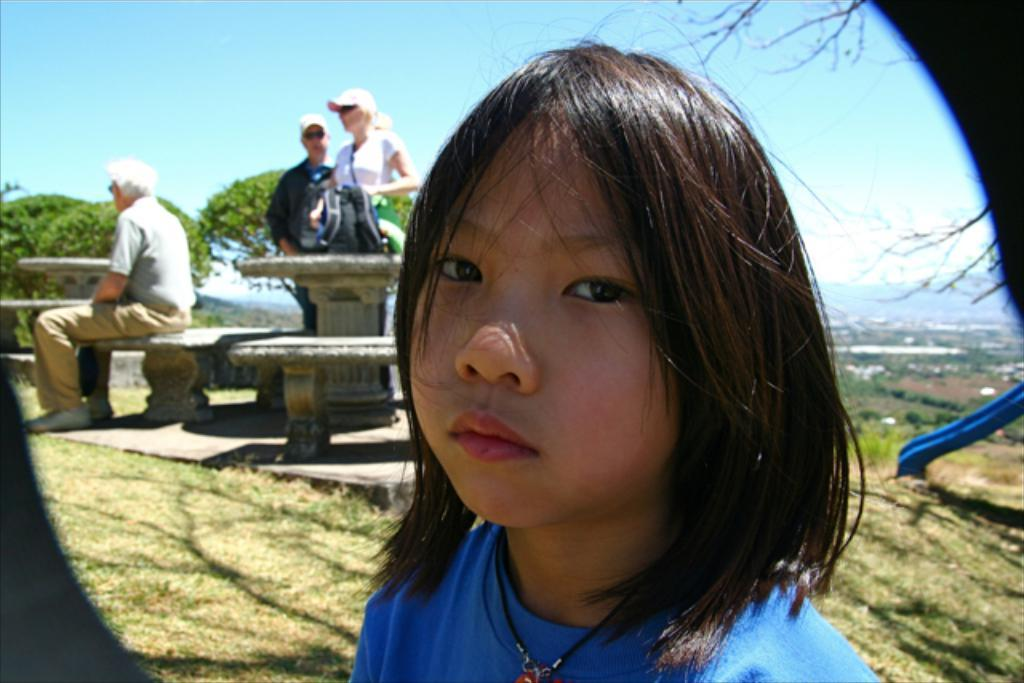Who is the main subject in the image? There is a girl in the image. Can you describe the girl's appearance? The girl has short hair and is wearing a blue t-shirt. How many people are visible in the image? There are three people behind the girl, but they are blurred. What type of vegetation can be seen in the image? There are plants visible in the image. What is the ground made of in the image? There is grass on the floor in the image. What type of pickle is the girl holding in the image? There is no pickle present in the image; the girl is not holding anything. Can you describe the slope of the hill in the image? There is no hill or slope present in the image. 